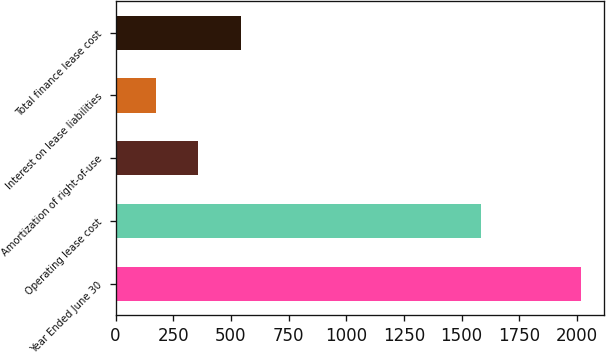<chart> <loc_0><loc_0><loc_500><loc_500><bar_chart><fcel>Year Ended June 30<fcel>Operating lease cost<fcel>Amortization of right-of-use<fcel>Interest on lease liabilities<fcel>Total finance lease cost<nl><fcel>2018<fcel>1585<fcel>359.3<fcel>175<fcel>543.6<nl></chart> 